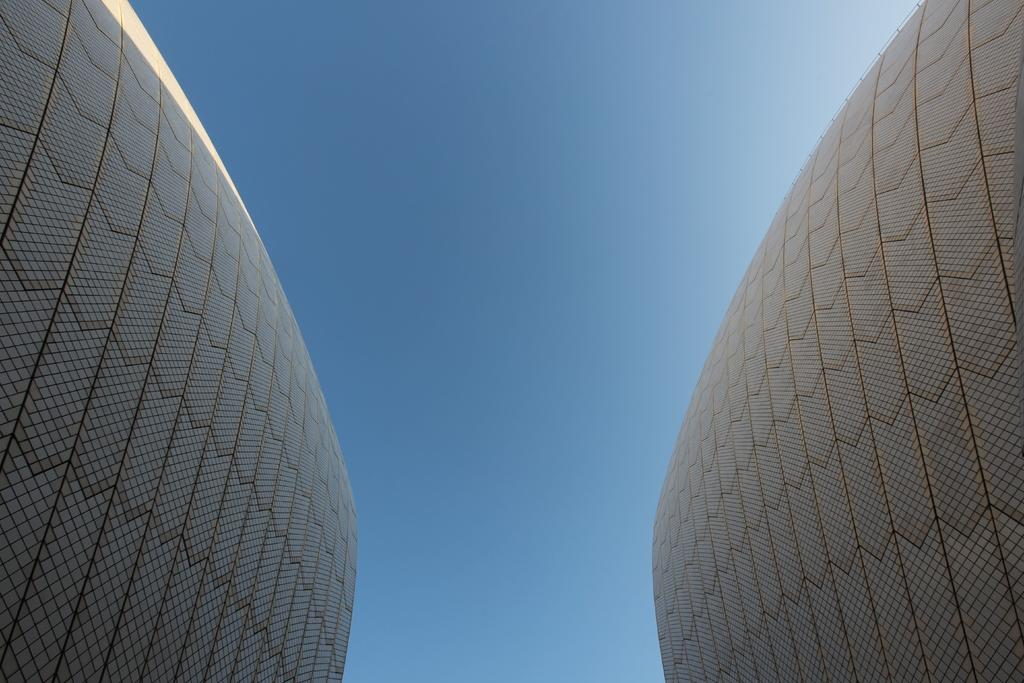What can be seen at the top of the image? The sky is visible in the image. What type of structures are present in the image? There are walls in the image. What type of dress is being measured with a needle in the image? There is no dress, measurement, or needle present in the image. 